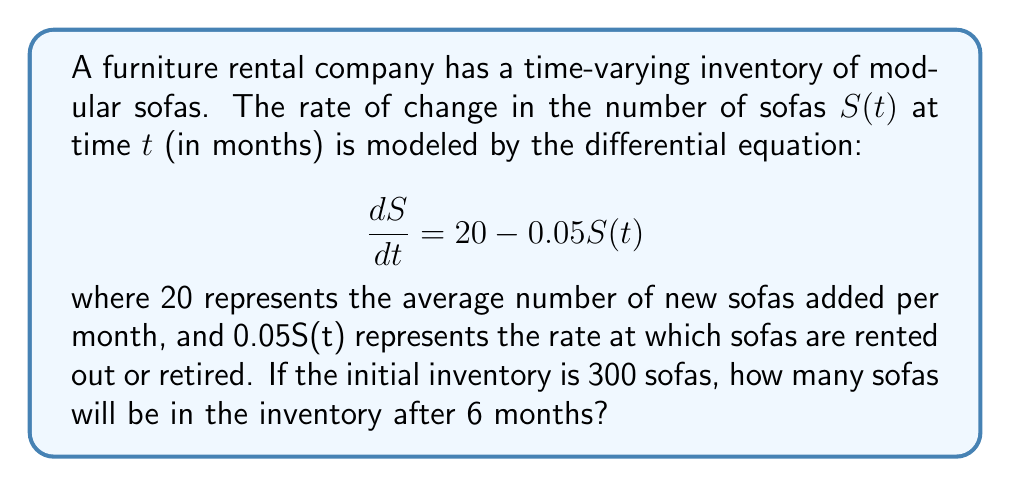Give your solution to this math problem. To solve this problem, we need to follow these steps:

1) First, we recognize this as a first-order linear differential equation.

2) The general solution for this type of equation is:

   $$S(t) = S_p + (S_0 - S_p)e^{-kt}$$

   where $S_p$ is the particular solution (steady-state value), $S_0$ is the initial value, and $k$ is the decay constant.

3) To find $S_p$, we set $\frac{dS}{dt} = 0$:

   $$0 = 20 - 0.05S_p$$
   $$S_p = \frac{20}{0.05} = 400$$

4) We're given that $S_0 = 300$ and $k = 0.05$.

5) Substituting these values into our general solution:

   $$S(t) = 400 + (300 - 400)e^{-0.05t}$$
   $$S(t) = 400 - 100e^{-0.05t}$$

6) Now we can calculate $S(6)$:

   $$S(6) = 400 - 100e^{-0.05(6)}$$
   $$S(6) = 400 - 100e^{-0.3}$$
   $$S(6) = 400 - 100(0.7408)$$
   $$S(6) = 400 - 74.08$$
   $$S(6) = 325.92$$

7) Rounding to the nearest whole number (as we can't have fractional sofas):

   $$S(6) \approx 326$$
Answer: After 6 months, there will be approximately 326 sofas in the inventory. 